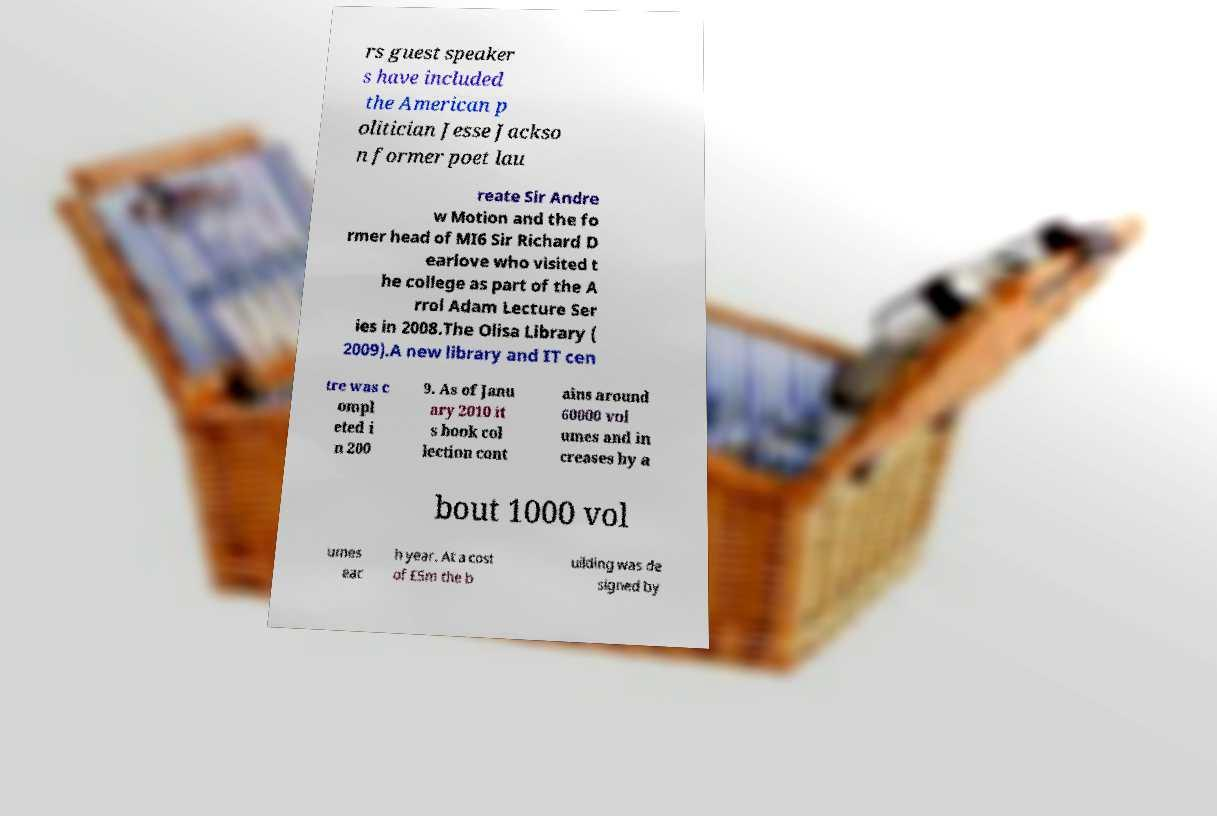For documentation purposes, I need the text within this image transcribed. Could you provide that? rs guest speaker s have included the American p olitician Jesse Jackso n former poet lau reate Sir Andre w Motion and the fo rmer head of MI6 Sir Richard D earlove who visited t he college as part of the A rrol Adam Lecture Ser ies in 2008.The Olisa Library ( 2009).A new library and IT cen tre was c ompl eted i n 200 9. As of Janu ary 2010 it s book col lection cont ains around 60000 vol umes and in creases by a bout 1000 vol umes eac h year. At a cost of £5m the b uilding was de signed by 